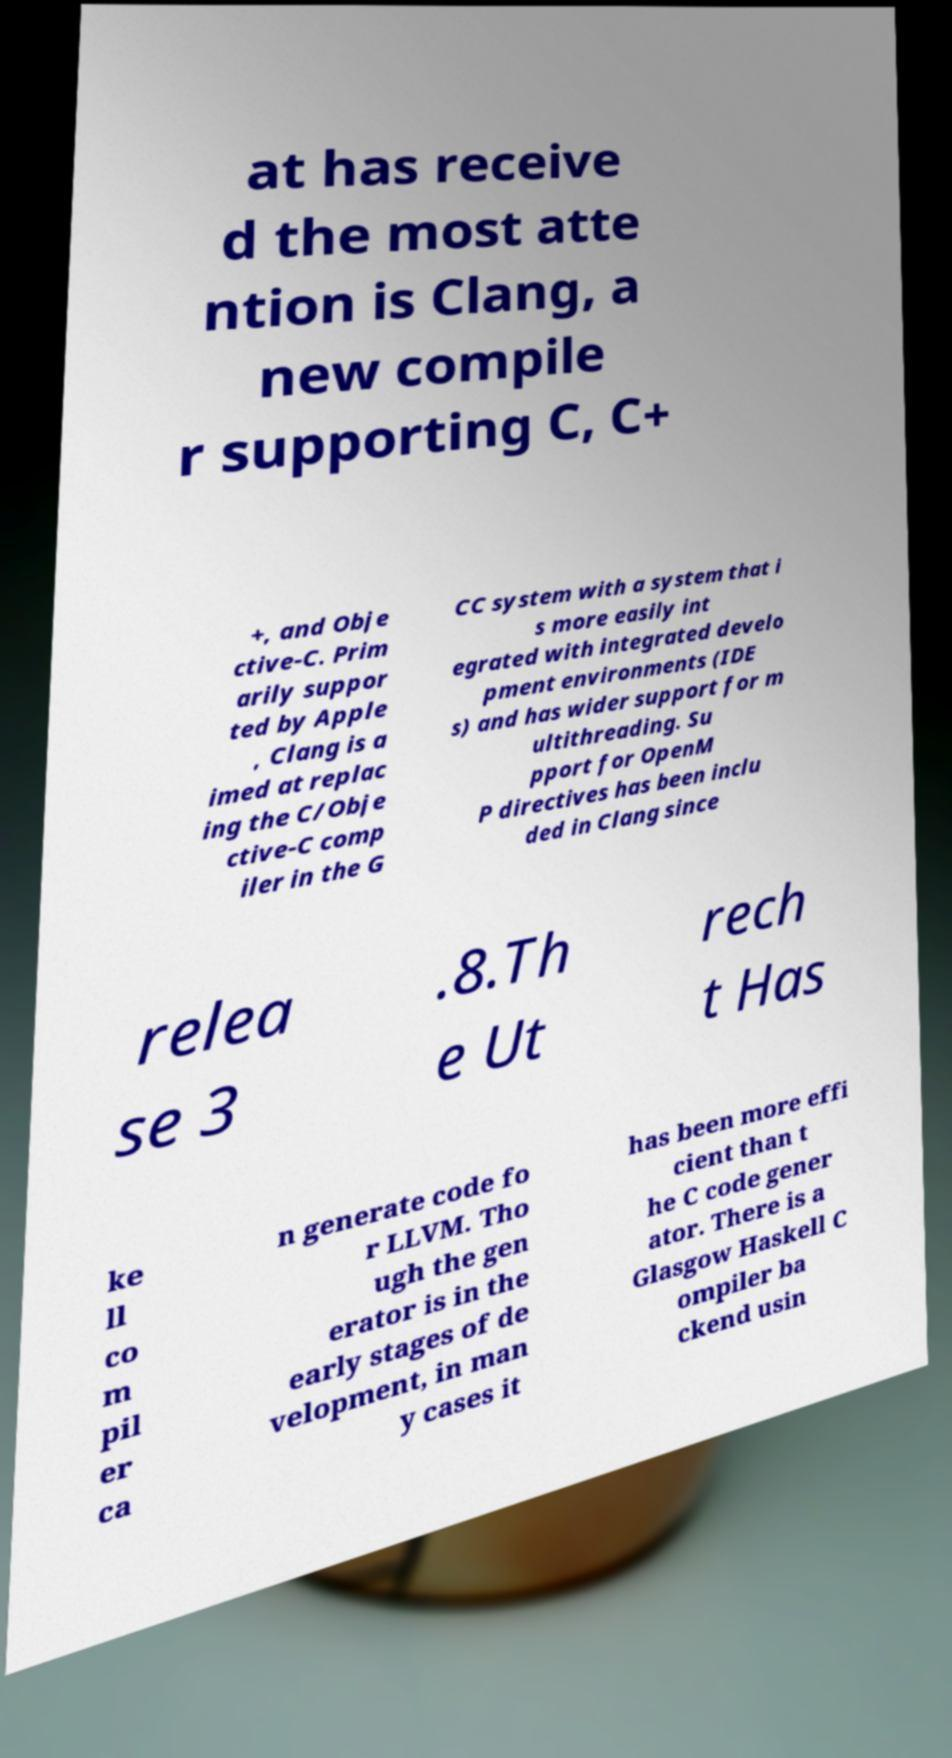For documentation purposes, I need the text within this image transcribed. Could you provide that? at has receive d the most atte ntion is Clang, a new compile r supporting C, C+ +, and Obje ctive-C. Prim arily suppor ted by Apple , Clang is a imed at replac ing the C/Obje ctive-C comp iler in the G CC system with a system that i s more easily int egrated with integrated develo pment environments (IDE s) and has wider support for m ultithreading. Su pport for OpenM P directives has been inclu ded in Clang since relea se 3 .8.Th e Ut rech t Has ke ll co m pil er ca n generate code fo r LLVM. Tho ugh the gen erator is in the early stages of de velopment, in man y cases it has been more effi cient than t he C code gener ator. There is a Glasgow Haskell C ompiler ba ckend usin 